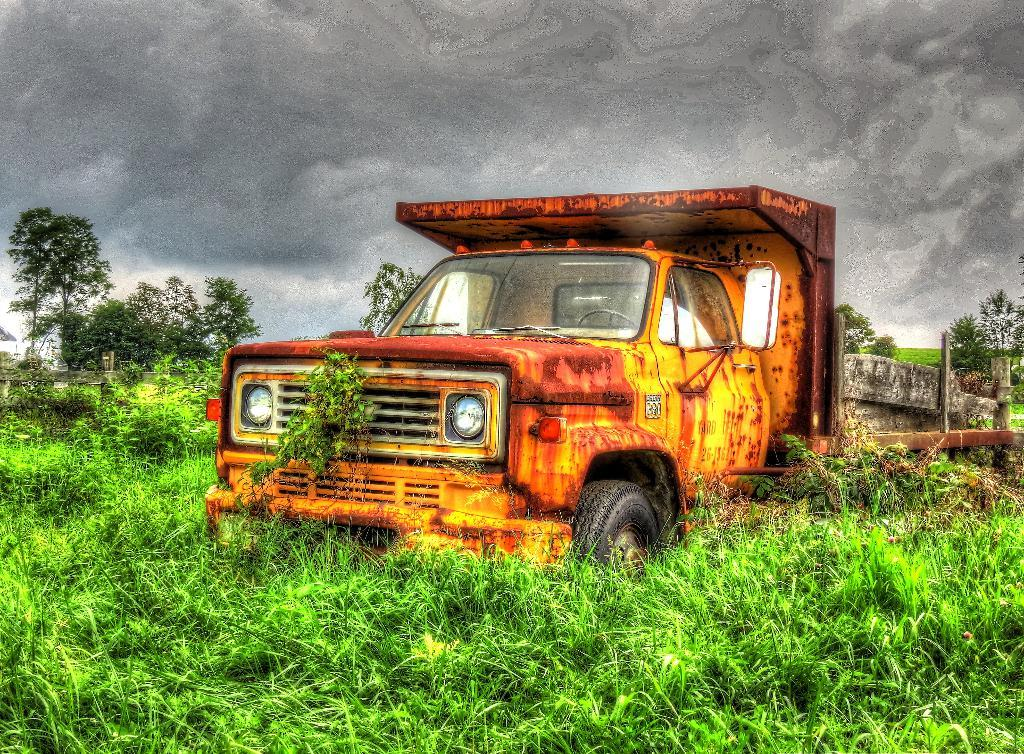What is the main subject of the image? The main subject of the image is a vehicle. Where is the vehicle located in the image? The vehicle is on the surface of the grass. What can be seen in the background of the image? There are trees and the sky visible in the background of the image. How many giraffes are standing next to the vehicle in the image? There are no giraffes present in the image. What type of vegetable is growing near the vehicle in the image? There is no vegetable visible in the image; the vehicle is on the grass, but no specific plants are mentioned. 